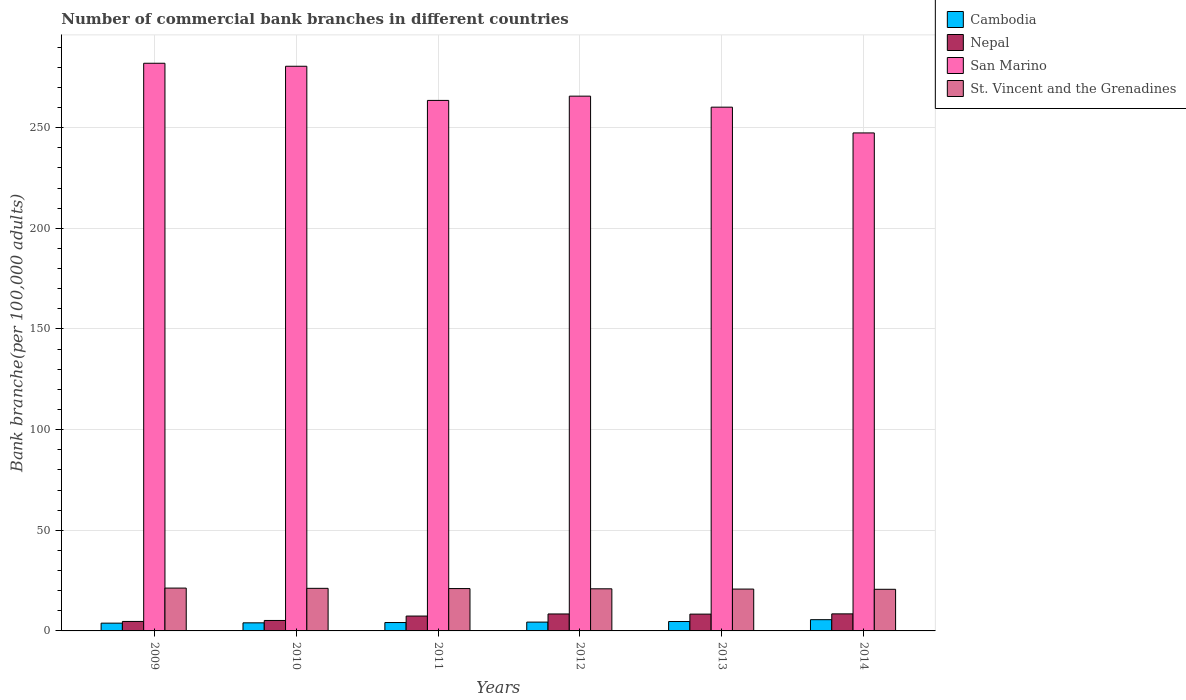How many groups of bars are there?
Offer a terse response. 6. Are the number of bars on each tick of the X-axis equal?
Offer a very short reply. Yes. What is the label of the 2nd group of bars from the left?
Offer a very short reply. 2010. In how many cases, is the number of bars for a given year not equal to the number of legend labels?
Make the answer very short. 0. What is the number of commercial bank branches in Cambodia in 2014?
Make the answer very short. 5.58. Across all years, what is the maximum number of commercial bank branches in Cambodia?
Your response must be concise. 5.58. Across all years, what is the minimum number of commercial bank branches in Nepal?
Keep it short and to the point. 4.71. What is the total number of commercial bank branches in St. Vincent and the Grenadines in the graph?
Ensure brevity in your answer.  125.89. What is the difference between the number of commercial bank branches in Cambodia in 2012 and that in 2014?
Keep it short and to the point. -1.2. What is the difference between the number of commercial bank branches in St. Vincent and the Grenadines in 2011 and the number of commercial bank branches in Nepal in 2013?
Your response must be concise. 12.69. What is the average number of commercial bank branches in St. Vincent and the Grenadines per year?
Provide a succinct answer. 20.98. In the year 2013, what is the difference between the number of commercial bank branches in San Marino and number of commercial bank branches in St. Vincent and the Grenadines?
Ensure brevity in your answer.  239.42. In how many years, is the number of commercial bank branches in Cambodia greater than 280?
Offer a very short reply. 0. What is the ratio of the number of commercial bank branches in Cambodia in 2009 to that in 2012?
Your answer should be very brief. 0.88. What is the difference between the highest and the second highest number of commercial bank branches in St. Vincent and the Grenadines?
Make the answer very short. 0.12. What is the difference between the highest and the lowest number of commercial bank branches in St. Vincent and the Grenadines?
Offer a very short reply. 0.6. In how many years, is the number of commercial bank branches in Cambodia greater than the average number of commercial bank branches in Cambodia taken over all years?
Ensure brevity in your answer.  2. Is it the case that in every year, the sum of the number of commercial bank branches in Nepal and number of commercial bank branches in St. Vincent and the Grenadines is greater than the sum of number of commercial bank branches in San Marino and number of commercial bank branches in Cambodia?
Your answer should be very brief. No. What does the 4th bar from the left in 2010 represents?
Make the answer very short. St. Vincent and the Grenadines. What does the 1st bar from the right in 2013 represents?
Offer a terse response. St. Vincent and the Grenadines. Is it the case that in every year, the sum of the number of commercial bank branches in Nepal and number of commercial bank branches in Cambodia is greater than the number of commercial bank branches in St. Vincent and the Grenadines?
Give a very brief answer. No. How many bars are there?
Offer a terse response. 24. Does the graph contain grids?
Offer a terse response. Yes. Where does the legend appear in the graph?
Provide a short and direct response. Top right. How are the legend labels stacked?
Offer a terse response. Vertical. What is the title of the graph?
Ensure brevity in your answer.  Number of commercial bank branches in different countries. Does "Korea (Republic)" appear as one of the legend labels in the graph?
Make the answer very short. No. What is the label or title of the Y-axis?
Give a very brief answer. Bank branche(per 100,0 adults). What is the Bank branche(per 100,000 adults) in Cambodia in 2009?
Provide a short and direct response. 3.86. What is the Bank branche(per 100,000 adults) of Nepal in 2009?
Offer a very short reply. 4.71. What is the Bank branche(per 100,000 adults) in San Marino in 2009?
Your answer should be very brief. 282.02. What is the Bank branche(per 100,000 adults) in St. Vincent and the Grenadines in 2009?
Your answer should be compact. 21.28. What is the Bank branche(per 100,000 adults) of Cambodia in 2010?
Offer a very short reply. 4.01. What is the Bank branche(per 100,000 adults) of Nepal in 2010?
Make the answer very short. 5.19. What is the Bank branche(per 100,000 adults) of San Marino in 2010?
Give a very brief answer. 280.53. What is the Bank branche(per 100,000 adults) in St. Vincent and the Grenadines in 2010?
Provide a short and direct response. 21.16. What is the Bank branche(per 100,000 adults) in Cambodia in 2011?
Give a very brief answer. 4.16. What is the Bank branche(per 100,000 adults) in Nepal in 2011?
Your answer should be very brief. 7.39. What is the Bank branche(per 100,000 adults) of San Marino in 2011?
Your answer should be very brief. 263.56. What is the Bank branche(per 100,000 adults) in St. Vincent and the Grenadines in 2011?
Give a very brief answer. 21.04. What is the Bank branche(per 100,000 adults) in Cambodia in 2012?
Provide a short and direct response. 4.38. What is the Bank branche(per 100,000 adults) of Nepal in 2012?
Your answer should be compact. 8.43. What is the Bank branche(per 100,000 adults) of San Marino in 2012?
Provide a succinct answer. 265.68. What is the Bank branche(per 100,000 adults) of St. Vincent and the Grenadines in 2012?
Give a very brief answer. 20.92. What is the Bank branche(per 100,000 adults) in Cambodia in 2013?
Ensure brevity in your answer.  4.67. What is the Bank branche(per 100,000 adults) of Nepal in 2013?
Offer a very short reply. 8.35. What is the Bank branche(per 100,000 adults) in San Marino in 2013?
Give a very brief answer. 260.21. What is the Bank branche(per 100,000 adults) of St. Vincent and the Grenadines in 2013?
Your answer should be compact. 20.8. What is the Bank branche(per 100,000 adults) in Cambodia in 2014?
Ensure brevity in your answer.  5.58. What is the Bank branche(per 100,000 adults) in Nepal in 2014?
Offer a very short reply. 8.47. What is the Bank branche(per 100,000 adults) of San Marino in 2014?
Give a very brief answer. 247.41. What is the Bank branche(per 100,000 adults) in St. Vincent and the Grenadines in 2014?
Ensure brevity in your answer.  20.69. Across all years, what is the maximum Bank branche(per 100,000 adults) in Cambodia?
Ensure brevity in your answer.  5.58. Across all years, what is the maximum Bank branche(per 100,000 adults) of Nepal?
Provide a short and direct response. 8.47. Across all years, what is the maximum Bank branche(per 100,000 adults) in San Marino?
Ensure brevity in your answer.  282.02. Across all years, what is the maximum Bank branche(per 100,000 adults) in St. Vincent and the Grenadines?
Ensure brevity in your answer.  21.28. Across all years, what is the minimum Bank branche(per 100,000 adults) in Cambodia?
Provide a short and direct response. 3.86. Across all years, what is the minimum Bank branche(per 100,000 adults) in Nepal?
Make the answer very short. 4.71. Across all years, what is the minimum Bank branche(per 100,000 adults) in San Marino?
Give a very brief answer. 247.41. Across all years, what is the minimum Bank branche(per 100,000 adults) in St. Vincent and the Grenadines?
Provide a succinct answer. 20.69. What is the total Bank branche(per 100,000 adults) of Cambodia in the graph?
Provide a short and direct response. 26.67. What is the total Bank branche(per 100,000 adults) of Nepal in the graph?
Your answer should be compact. 42.54. What is the total Bank branche(per 100,000 adults) of San Marino in the graph?
Provide a succinct answer. 1599.42. What is the total Bank branche(per 100,000 adults) of St. Vincent and the Grenadines in the graph?
Your answer should be compact. 125.89. What is the difference between the Bank branche(per 100,000 adults) in Cambodia in 2009 and that in 2010?
Your response must be concise. -0.15. What is the difference between the Bank branche(per 100,000 adults) of Nepal in 2009 and that in 2010?
Give a very brief answer. -0.49. What is the difference between the Bank branche(per 100,000 adults) in San Marino in 2009 and that in 2010?
Make the answer very short. 1.49. What is the difference between the Bank branche(per 100,000 adults) in St. Vincent and the Grenadines in 2009 and that in 2010?
Offer a very short reply. 0.12. What is the difference between the Bank branche(per 100,000 adults) in Cambodia in 2009 and that in 2011?
Your answer should be very brief. -0.3. What is the difference between the Bank branche(per 100,000 adults) in Nepal in 2009 and that in 2011?
Offer a very short reply. -2.68. What is the difference between the Bank branche(per 100,000 adults) in San Marino in 2009 and that in 2011?
Make the answer very short. 18.46. What is the difference between the Bank branche(per 100,000 adults) in St. Vincent and the Grenadines in 2009 and that in 2011?
Provide a short and direct response. 0.24. What is the difference between the Bank branche(per 100,000 adults) in Cambodia in 2009 and that in 2012?
Make the answer very short. -0.52. What is the difference between the Bank branche(per 100,000 adults) in Nepal in 2009 and that in 2012?
Provide a short and direct response. -3.72. What is the difference between the Bank branche(per 100,000 adults) of San Marino in 2009 and that in 2012?
Offer a terse response. 16.34. What is the difference between the Bank branche(per 100,000 adults) in St. Vincent and the Grenadines in 2009 and that in 2012?
Your answer should be compact. 0.36. What is the difference between the Bank branche(per 100,000 adults) in Cambodia in 2009 and that in 2013?
Your answer should be compact. -0.81. What is the difference between the Bank branche(per 100,000 adults) in Nepal in 2009 and that in 2013?
Your answer should be compact. -3.64. What is the difference between the Bank branche(per 100,000 adults) in San Marino in 2009 and that in 2013?
Offer a terse response. 21.81. What is the difference between the Bank branche(per 100,000 adults) of St. Vincent and the Grenadines in 2009 and that in 2013?
Keep it short and to the point. 0.49. What is the difference between the Bank branche(per 100,000 adults) in Cambodia in 2009 and that in 2014?
Offer a very short reply. -1.72. What is the difference between the Bank branche(per 100,000 adults) of Nepal in 2009 and that in 2014?
Keep it short and to the point. -3.76. What is the difference between the Bank branche(per 100,000 adults) in San Marino in 2009 and that in 2014?
Provide a succinct answer. 34.61. What is the difference between the Bank branche(per 100,000 adults) of St. Vincent and the Grenadines in 2009 and that in 2014?
Give a very brief answer. 0.6. What is the difference between the Bank branche(per 100,000 adults) in Cambodia in 2010 and that in 2011?
Provide a succinct answer. -0.15. What is the difference between the Bank branche(per 100,000 adults) of Nepal in 2010 and that in 2011?
Your answer should be very brief. -2.19. What is the difference between the Bank branche(per 100,000 adults) in San Marino in 2010 and that in 2011?
Give a very brief answer. 16.97. What is the difference between the Bank branche(per 100,000 adults) of St. Vincent and the Grenadines in 2010 and that in 2011?
Give a very brief answer. 0.12. What is the difference between the Bank branche(per 100,000 adults) in Cambodia in 2010 and that in 2012?
Make the answer very short. -0.37. What is the difference between the Bank branche(per 100,000 adults) in Nepal in 2010 and that in 2012?
Your response must be concise. -3.23. What is the difference between the Bank branche(per 100,000 adults) of San Marino in 2010 and that in 2012?
Make the answer very short. 14.85. What is the difference between the Bank branche(per 100,000 adults) of St. Vincent and the Grenadines in 2010 and that in 2012?
Your answer should be very brief. 0.24. What is the difference between the Bank branche(per 100,000 adults) in Cambodia in 2010 and that in 2013?
Make the answer very short. -0.66. What is the difference between the Bank branche(per 100,000 adults) of Nepal in 2010 and that in 2013?
Your answer should be compact. -3.16. What is the difference between the Bank branche(per 100,000 adults) of San Marino in 2010 and that in 2013?
Provide a short and direct response. 20.32. What is the difference between the Bank branche(per 100,000 adults) in St. Vincent and the Grenadines in 2010 and that in 2013?
Provide a succinct answer. 0.36. What is the difference between the Bank branche(per 100,000 adults) in Cambodia in 2010 and that in 2014?
Ensure brevity in your answer.  -1.57. What is the difference between the Bank branche(per 100,000 adults) in Nepal in 2010 and that in 2014?
Your response must be concise. -3.28. What is the difference between the Bank branche(per 100,000 adults) of San Marino in 2010 and that in 2014?
Offer a terse response. 33.12. What is the difference between the Bank branche(per 100,000 adults) of St. Vincent and the Grenadines in 2010 and that in 2014?
Your response must be concise. 0.47. What is the difference between the Bank branche(per 100,000 adults) in Cambodia in 2011 and that in 2012?
Your answer should be compact. -0.22. What is the difference between the Bank branche(per 100,000 adults) of Nepal in 2011 and that in 2012?
Your answer should be compact. -1.04. What is the difference between the Bank branche(per 100,000 adults) in San Marino in 2011 and that in 2012?
Your response must be concise. -2.12. What is the difference between the Bank branche(per 100,000 adults) in St. Vincent and the Grenadines in 2011 and that in 2012?
Ensure brevity in your answer.  0.12. What is the difference between the Bank branche(per 100,000 adults) in Cambodia in 2011 and that in 2013?
Your answer should be compact. -0.5. What is the difference between the Bank branche(per 100,000 adults) of Nepal in 2011 and that in 2013?
Provide a succinct answer. -0.97. What is the difference between the Bank branche(per 100,000 adults) in San Marino in 2011 and that in 2013?
Keep it short and to the point. 3.35. What is the difference between the Bank branche(per 100,000 adults) in St. Vincent and the Grenadines in 2011 and that in 2013?
Provide a short and direct response. 0.24. What is the difference between the Bank branche(per 100,000 adults) of Cambodia in 2011 and that in 2014?
Offer a terse response. -1.42. What is the difference between the Bank branche(per 100,000 adults) in Nepal in 2011 and that in 2014?
Ensure brevity in your answer.  -1.09. What is the difference between the Bank branche(per 100,000 adults) in San Marino in 2011 and that in 2014?
Offer a terse response. 16.15. What is the difference between the Bank branche(per 100,000 adults) of St. Vincent and the Grenadines in 2011 and that in 2014?
Give a very brief answer. 0.35. What is the difference between the Bank branche(per 100,000 adults) of Cambodia in 2012 and that in 2013?
Offer a terse response. -0.29. What is the difference between the Bank branche(per 100,000 adults) in Nepal in 2012 and that in 2013?
Give a very brief answer. 0.08. What is the difference between the Bank branche(per 100,000 adults) in San Marino in 2012 and that in 2013?
Offer a terse response. 5.47. What is the difference between the Bank branche(per 100,000 adults) in St. Vincent and the Grenadines in 2012 and that in 2013?
Provide a short and direct response. 0.12. What is the difference between the Bank branche(per 100,000 adults) of Cambodia in 2012 and that in 2014?
Keep it short and to the point. -1.2. What is the difference between the Bank branche(per 100,000 adults) of Nepal in 2012 and that in 2014?
Your answer should be very brief. -0.04. What is the difference between the Bank branche(per 100,000 adults) in San Marino in 2012 and that in 2014?
Ensure brevity in your answer.  18.27. What is the difference between the Bank branche(per 100,000 adults) of St. Vincent and the Grenadines in 2012 and that in 2014?
Your answer should be compact. 0.23. What is the difference between the Bank branche(per 100,000 adults) of Cambodia in 2013 and that in 2014?
Provide a succinct answer. -0.92. What is the difference between the Bank branche(per 100,000 adults) in Nepal in 2013 and that in 2014?
Your response must be concise. -0.12. What is the difference between the Bank branche(per 100,000 adults) in San Marino in 2013 and that in 2014?
Keep it short and to the point. 12.8. What is the difference between the Bank branche(per 100,000 adults) of St. Vincent and the Grenadines in 2013 and that in 2014?
Ensure brevity in your answer.  0.11. What is the difference between the Bank branche(per 100,000 adults) of Cambodia in 2009 and the Bank branche(per 100,000 adults) of Nepal in 2010?
Make the answer very short. -1.33. What is the difference between the Bank branche(per 100,000 adults) of Cambodia in 2009 and the Bank branche(per 100,000 adults) of San Marino in 2010?
Keep it short and to the point. -276.67. What is the difference between the Bank branche(per 100,000 adults) of Cambodia in 2009 and the Bank branche(per 100,000 adults) of St. Vincent and the Grenadines in 2010?
Your answer should be very brief. -17.3. What is the difference between the Bank branche(per 100,000 adults) in Nepal in 2009 and the Bank branche(per 100,000 adults) in San Marino in 2010?
Provide a short and direct response. -275.82. What is the difference between the Bank branche(per 100,000 adults) in Nepal in 2009 and the Bank branche(per 100,000 adults) in St. Vincent and the Grenadines in 2010?
Offer a very short reply. -16.45. What is the difference between the Bank branche(per 100,000 adults) in San Marino in 2009 and the Bank branche(per 100,000 adults) in St. Vincent and the Grenadines in 2010?
Provide a succinct answer. 260.86. What is the difference between the Bank branche(per 100,000 adults) in Cambodia in 2009 and the Bank branche(per 100,000 adults) in Nepal in 2011?
Your answer should be very brief. -3.52. What is the difference between the Bank branche(per 100,000 adults) in Cambodia in 2009 and the Bank branche(per 100,000 adults) in San Marino in 2011?
Ensure brevity in your answer.  -259.7. What is the difference between the Bank branche(per 100,000 adults) in Cambodia in 2009 and the Bank branche(per 100,000 adults) in St. Vincent and the Grenadines in 2011?
Offer a very short reply. -17.18. What is the difference between the Bank branche(per 100,000 adults) in Nepal in 2009 and the Bank branche(per 100,000 adults) in San Marino in 2011?
Ensure brevity in your answer.  -258.86. What is the difference between the Bank branche(per 100,000 adults) of Nepal in 2009 and the Bank branche(per 100,000 adults) of St. Vincent and the Grenadines in 2011?
Ensure brevity in your answer.  -16.33. What is the difference between the Bank branche(per 100,000 adults) in San Marino in 2009 and the Bank branche(per 100,000 adults) in St. Vincent and the Grenadines in 2011?
Offer a terse response. 260.98. What is the difference between the Bank branche(per 100,000 adults) of Cambodia in 2009 and the Bank branche(per 100,000 adults) of Nepal in 2012?
Your response must be concise. -4.57. What is the difference between the Bank branche(per 100,000 adults) of Cambodia in 2009 and the Bank branche(per 100,000 adults) of San Marino in 2012?
Keep it short and to the point. -261.82. What is the difference between the Bank branche(per 100,000 adults) in Cambodia in 2009 and the Bank branche(per 100,000 adults) in St. Vincent and the Grenadines in 2012?
Your answer should be compact. -17.06. What is the difference between the Bank branche(per 100,000 adults) of Nepal in 2009 and the Bank branche(per 100,000 adults) of San Marino in 2012?
Your answer should be very brief. -260.97. What is the difference between the Bank branche(per 100,000 adults) of Nepal in 2009 and the Bank branche(per 100,000 adults) of St. Vincent and the Grenadines in 2012?
Make the answer very short. -16.21. What is the difference between the Bank branche(per 100,000 adults) in San Marino in 2009 and the Bank branche(per 100,000 adults) in St. Vincent and the Grenadines in 2012?
Offer a terse response. 261.1. What is the difference between the Bank branche(per 100,000 adults) of Cambodia in 2009 and the Bank branche(per 100,000 adults) of Nepal in 2013?
Ensure brevity in your answer.  -4.49. What is the difference between the Bank branche(per 100,000 adults) in Cambodia in 2009 and the Bank branche(per 100,000 adults) in San Marino in 2013?
Provide a succinct answer. -256.35. What is the difference between the Bank branche(per 100,000 adults) in Cambodia in 2009 and the Bank branche(per 100,000 adults) in St. Vincent and the Grenadines in 2013?
Your answer should be compact. -16.93. What is the difference between the Bank branche(per 100,000 adults) in Nepal in 2009 and the Bank branche(per 100,000 adults) in San Marino in 2013?
Your answer should be very brief. -255.5. What is the difference between the Bank branche(per 100,000 adults) of Nepal in 2009 and the Bank branche(per 100,000 adults) of St. Vincent and the Grenadines in 2013?
Give a very brief answer. -16.09. What is the difference between the Bank branche(per 100,000 adults) in San Marino in 2009 and the Bank branche(per 100,000 adults) in St. Vincent and the Grenadines in 2013?
Offer a terse response. 261.23. What is the difference between the Bank branche(per 100,000 adults) in Cambodia in 2009 and the Bank branche(per 100,000 adults) in Nepal in 2014?
Keep it short and to the point. -4.61. What is the difference between the Bank branche(per 100,000 adults) of Cambodia in 2009 and the Bank branche(per 100,000 adults) of San Marino in 2014?
Your response must be concise. -243.55. What is the difference between the Bank branche(per 100,000 adults) in Cambodia in 2009 and the Bank branche(per 100,000 adults) in St. Vincent and the Grenadines in 2014?
Your response must be concise. -16.83. What is the difference between the Bank branche(per 100,000 adults) in Nepal in 2009 and the Bank branche(per 100,000 adults) in San Marino in 2014?
Keep it short and to the point. -242.7. What is the difference between the Bank branche(per 100,000 adults) in Nepal in 2009 and the Bank branche(per 100,000 adults) in St. Vincent and the Grenadines in 2014?
Keep it short and to the point. -15.98. What is the difference between the Bank branche(per 100,000 adults) of San Marino in 2009 and the Bank branche(per 100,000 adults) of St. Vincent and the Grenadines in 2014?
Provide a short and direct response. 261.33. What is the difference between the Bank branche(per 100,000 adults) of Cambodia in 2010 and the Bank branche(per 100,000 adults) of Nepal in 2011?
Give a very brief answer. -3.37. What is the difference between the Bank branche(per 100,000 adults) in Cambodia in 2010 and the Bank branche(per 100,000 adults) in San Marino in 2011?
Give a very brief answer. -259.55. What is the difference between the Bank branche(per 100,000 adults) of Cambodia in 2010 and the Bank branche(per 100,000 adults) of St. Vincent and the Grenadines in 2011?
Ensure brevity in your answer.  -17.02. What is the difference between the Bank branche(per 100,000 adults) of Nepal in 2010 and the Bank branche(per 100,000 adults) of San Marino in 2011?
Provide a succinct answer. -258.37. What is the difference between the Bank branche(per 100,000 adults) of Nepal in 2010 and the Bank branche(per 100,000 adults) of St. Vincent and the Grenadines in 2011?
Make the answer very short. -15.84. What is the difference between the Bank branche(per 100,000 adults) in San Marino in 2010 and the Bank branche(per 100,000 adults) in St. Vincent and the Grenadines in 2011?
Your answer should be very brief. 259.49. What is the difference between the Bank branche(per 100,000 adults) in Cambodia in 2010 and the Bank branche(per 100,000 adults) in Nepal in 2012?
Provide a succinct answer. -4.42. What is the difference between the Bank branche(per 100,000 adults) in Cambodia in 2010 and the Bank branche(per 100,000 adults) in San Marino in 2012?
Your answer should be very brief. -261.67. What is the difference between the Bank branche(per 100,000 adults) in Cambodia in 2010 and the Bank branche(per 100,000 adults) in St. Vincent and the Grenadines in 2012?
Offer a very short reply. -16.91. What is the difference between the Bank branche(per 100,000 adults) of Nepal in 2010 and the Bank branche(per 100,000 adults) of San Marino in 2012?
Offer a very short reply. -260.49. What is the difference between the Bank branche(per 100,000 adults) of Nepal in 2010 and the Bank branche(per 100,000 adults) of St. Vincent and the Grenadines in 2012?
Give a very brief answer. -15.73. What is the difference between the Bank branche(per 100,000 adults) in San Marino in 2010 and the Bank branche(per 100,000 adults) in St. Vincent and the Grenadines in 2012?
Ensure brevity in your answer.  259.61. What is the difference between the Bank branche(per 100,000 adults) in Cambodia in 2010 and the Bank branche(per 100,000 adults) in Nepal in 2013?
Provide a short and direct response. -4.34. What is the difference between the Bank branche(per 100,000 adults) in Cambodia in 2010 and the Bank branche(per 100,000 adults) in San Marino in 2013?
Offer a terse response. -256.2. What is the difference between the Bank branche(per 100,000 adults) of Cambodia in 2010 and the Bank branche(per 100,000 adults) of St. Vincent and the Grenadines in 2013?
Offer a very short reply. -16.78. What is the difference between the Bank branche(per 100,000 adults) in Nepal in 2010 and the Bank branche(per 100,000 adults) in San Marino in 2013?
Ensure brevity in your answer.  -255.02. What is the difference between the Bank branche(per 100,000 adults) of Nepal in 2010 and the Bank branche(per 100,000 adults) of St. Vincent and the Grenadines in 2013?
Provide a succinct answer. -15.6. What is the difference between the Bank branche(per 100,000 adults) of San Marino in 2010 and the Bank branche(per 100,000 adults) of St. Vincent and the Grenadines in 2013?
Offer a very short reply. 259.74. What is the difference between the Bank branche(per 100,000 adults) in Cambodia in 2010 and the Bank branche(per 100,000 adults) in Nepal in 2014?
Your response must be concise. -4.46. What is the difference between the Bank branche(per 100,000 adults) of Cambodia in 2010 and the Bank branche(per 100,000 adults) of San Marino in 2014?
Give a very brief answer. -243.4. What is the difference between the Bank branche(per 100,000 adults) in Cambodia in 2010 and the Bank branche(per 100,000 adults) in St. Vincent and the Grenadines in 2014?
Your answer should be very brief. -16.67. What is the difference between the Bank branche(per 100,000 adults) of Nepal in 2010 and the Bank branche(per 100,000 adults) of San Marino in 2014?
Make the answer very short. -242.22. What is the difference between the Bank branche(per 100,000 adults) of Nepal in 2010 and the Bank branche(per 100,000 adults) of St. Vincent and the Grenadines in 2014?
Your response must be concise. -15.49. What is the difference between the Bank branche(per 100,000 adults) in San Marino in 2010 and the Bank branche(per 100,000 adults) in St. Vincent and the Grenadines in 2014?
Your answer should be very brief. 259.84. What is the difference between the Bank branche(per 100,000 adults) in Cambodia in 2011 and the Bank branche(per 100,000 adults) in Nepal in 2012?
Provide a succinct answer. -4.26. What is the difference between the Bank branche(per 100,000 adults) of Cambodia in 2011 and the Bank branche(per 100,000 adults) of San Marino in 2012?
Provide a succinct answer. -261.52. What is the difference between the Bank branche(per 100,000 adults) in Cambodia in 2011 and the Bank branche(per 100,000 adults) in St. Vincent and the Grenadines in 2012?
Provide a short and direct response. -16.76. What is the difference between the Bank branche(per 100,000 adults) in Nepal in 2011 and the Bank branche(per 100,000 adults) in San Marino in 2012?
Your answer should be compact. -258.29. What is the difference between the Bank branche(per 100,000 adults) in Nepal in 2011 and the Bank branche(per 100,000 adults) in St. Vincent and the Grenadines in 2012?
Offer a terse response. -13.53. What is the difference between the Bank branche(per 100,000 adults) of San Marino in 2011 and the Bank branche(per 100,000 adults) of St. Vincent and the Grenadines in 2012?
Keep it short and to the point. 242.64. What is the difference between the Bank branche(per 100,000 adults) of Cambodia in 2011 and the Bank branche(per 100,000 adults) of Nepal in 2013?
Your answer should be compact. -4.19. What is the difference between the Bank branche(per 100,000 adults) in Cambodia in 2011 and the Bank branche(per 100,000 adults) in San Marino in 2013?
Offer a terse response. -256.05. What is the difference between the Bank branche(per 100,000 adults) in Cambodia in 2011 and the Bank branche(per 100,000 adults) in St. Vincent and the Grenadines in 2013?
Offer a terse response. -16.63. What is the difference between the Bank branche(per 100,000 adults) of Nepal in 2011 and the Bank branche(per 100,000 adults) of San Marino in 2013?
Your response must be concise. -252.83. What is the difference between the Bank branche(per 100,000 adults) in Nepal in 2011 and the Bank branche(per 100,000 adults) in St. Vincent and the Grenadines in 2013?
Keep it short and to the point. -13.41. What is the difference between the Bank branche(per 100,000 adults) of San Marino in 2011 and the Bank branche(per 100,000 adults) of St. Vincent and the Grenadines in 2013?
Your answer should be very brief. 242.77. What is the difference between the Bank branche(per 100,000 adults) of Cambodia in 2011 and the Bank branche(per 100,000 adults) of Nepal in 2014?
Provide a succinct answer. -4.31. What is the difference between the Bank branche(per 100,000 adults) in Cambodia in 2011 and the Bank branche(per 100,000 adults) in San Marino in 2014?
Give a very brief answer. -243.25. What is the difference between the Bank branche(per 100,000 adults) in Cambodia in 2011 and the Bank branche(per 100,000 adults) in St. Vincent and the Grenadines in 2014?
Make the answer very short. -16.52. What is the difference between the Bank branche(per 100,000 adults) in Nepal in 2011 and the Bank branche(per 100,000 adults) in San Marino in 2014?
Ensure brevity in your answer.  -240.02. What is the difference between the Bank branche(per 100,000 adults) of Nepal in 2011 and the Bank branche(per 100,000 adults) of St. Vincent and the Grenadines in 2014?
Ensure brevity in your answer.  -13.3. What is the difference between the Bank branche(per 100,000 adults) of San Marino in 2011 and the Bank branche(per 100,000 adults) of St. Vincent and the Grenadines in 2014?
Keep it short and to the point. 242.88. What is the difference between the Bank branche(per 100,000 adults) of Cambodia in 2012 and the Bank branche(per 100,000 adults) of Nepal in 2013?
Your answer should be compact. -3.97. What is the difference between the Bank branche(per 100,000 adults) of Cambodia in 2012 and the Bank branche(per 100,000 adults) of San Marino in 2013?
Give a very brief answer. -255.83. What is the difference between the Bank branche(per 100,000 adults) in Cambodia in 2012 and the Bank branche(per 100,000 adults) in St. Vincent and the Grenadines in 2013?
Your response must be concise. -16.41. What is the difference between the Bank branche(per 100,000 adults) in Nepal in 2012 and the Bank branche(per 100,000 adults) in San Marino in 2013?
Your answer should be very brief. -251.78. What is the difference between the Bank branche(per 100,000 adults) of Nepal in 2012 and the Bank branche(per 100,000 adults) of St. Vincent and the Grenadines in 2013?
Keep it short and to the point. -12.37. What is the difference between the Bank branche(per 100,000 adults) in San Marino in 2012 and the Bank branche(per 100,000 adults) in St. Vincent and the Grenadines in 2013?
Give a very brief answer. 244.88. What is the difference between the Bank branche(per 100,000 adults) of Cambodia in 2012 and the Bank branche(per 100,000 adults) of Nepal in 2014?
Ensure brevity in your answer.  -4.09. What is the difference between the Bank branche(per 100,000 adults) in Cambodia in 2012 and the Bank branche(per 100,000 adults) in San Marino in 2014?
Your answer should be very brief. -243.03. What is the difference between the Bank branche(per 100,000 adults) of Cambodia in 2012 and the Bank branche(per 100,000 adults) of St. Vincent and the Grenadines in 2014?
Make the answer very short. -16.3. What is the difference between the Bank branche(per 100,000 adults) in Nepal in 2012 and the Bank branche(per 100,000 adults) in San Marino in 2014?
Provide a succinct answer. -238.98. What is the difference between the Bank branche(per 100,000 adults) of Nepal in 2012 and the Bank branche(per 100,000 adults) of St. Vincent and the Grenadines in 2014?
Provide a succinct answer. -12.26. What is the difference between the Bank branche(per 100,000 adults) in San Marino in 2012 and the Bank branche(per 100,000 adults) in St. Vincent and the Grenadines in 2014?
Your response must be concise. 244.99. What is the difference between the Bank branche(per 100,000 adults) of Cambodia in 2013 and the Bank branche(per 100,000 adults) of Nepal in 2014?
Offer a very short reply. -3.8. What is the difference between the Bank branche(per 100,000 adults) of Cambodia in 2013 and the Bank branche(per 100,000 adults) of San Marino in 2014?
Make the answer very short. -242.74. What is the difference between the Bank branche(per 100,000 adults) in Cambodia in 2013 and the Bank branche(per 100,000 adults) in St. Vincent and the Grenadines in 2014?
Give a very brief answer. -16.02. What is the difference between the Bank branche(per 100,000 adults) in Nepal in 2013 and the Bank branche(per 100,000 adults) in San Marino in 2014?
Keep it short and to the point. -239.06. What is the difference between the Bank branche(per 100,000 adults) of Nepal in 2013 and the Bank branche(per 100,000 adults) of St. Vincent and the Grenadines in 2014?
Ensure brevity in your answer.  -12.34. What is the difference between the Bank branche(per 100,000 adults) of San Marino in 2013 and the Bank branche(per 100,000 adults) of St. Vincent and the Grenadines in 2014?
Offer a very short reply. 239.52. What is the average Bank branche(per 100,000 adults) of Cambodia per year?
Offer a very short reply. 4.45. What is the average Bank branche(per 100,000 adults) of Nepal per year?
Give a very brief answer. 7.09. What is the average Bank branche(per 100,000 adults) of San Marino per year?
Offer a very short reply. 266.57. What is the average Bank branche(per 100,000 adults) of St. Vincent and the Grenadines per year?
Make the answer very short. 20.98. In the year 2009, what is the difference between the Bank branche(per 100,000 adults) in Cambodia and Bank branche(per 100,000 adults) in Nepal?
Your answer should be very brief. -0.85. In the year 2009, what is the difference between the Bank branche(per 100,000 adults) in Cambodia and Bank branche(per 100,000 adults) in San Marino?
Give a very brief answer. -278.16. In the year 2009, what is the difference between the Bank branche(per 100,000 adults) in Cambodia and Bank branche(per 100,000 adults) in St. Vincent and the Grenadines?
Your answer should be compact. -17.42. In the year 2009, what is the difference between the Bank branche(per 100,000 adults) in Nepal and Bank branche(per 100,000 adults) in San Marino?
Your answer should be compact. -277.31. In the year 2009, what is the difference between the Bank branche(per 100,000 adults) in Nepal and Bank branche(per 100,000 adults) in St. Vincent and the Grenadines?
Provide a short and direct response. -16.58. In the year 2009, what is the difference between the Bank branche(per 100,000 adults) in San Marino and Bank branche(per 100,000 adults) in St. Vincent and the Grenadines?
Give a very brief answer. 260.74. In the year 2010, what is the difference between the Bank branche(per 100,000 adults) in Cambodia and Bank branche(per 100,000 adults) in Nepal?
Keep it short and to the point. -1.18. In the year 2010, what is the difference between the Bank branche(per 100,000 adults) in Cambodia and Bank branche(per 100,000 adults) in San Marino?
Make the answer very short. -276.52. In the year 2010, what is the difference between the Bank branche(per 100,000 adults) in Cambodia and Bank branche(per 100,000 adults) in St. Vincent and the Grenadines?
Your response must be concise. -17.15. In the year 2010, what is the difference between the Bank branche(per 100,000 adults) in Nepal and Bank branche(per 100,000 adults) in San Marino?
Your answer should be compact. -275.34. In the year 2010, what is the difference between the Bank branche(per 100,000 adults) of Nepal and Bank branche(per 100,000 adults) of St. Vincent and the Grenadines?
Your answer should be compact. -15.97. In the year 2010, what is the difference between the Bank branche(per 100,000 adults) in San Marino and Bank branche(per 100,000 adults) in St. Vincent and the Grenadines?
Your answer should be compact. 259.37. In the year 2011, what is the difference between the Bank branche(per 100,000 adults) in Cambodia and Bank branche(per 100,000 adults) in Nepal?
Make the answer very short. -3.22. In the year 2011, what is the difference between the Bank branche(per 100,000 adults) of Cambodia and Bank branche(per 100,000 adults) of San Marino?
Your response must be concise. -259.4. In the year 2011, what is the difference between the Bank branche(per 100,000 adults) of Cambodia and Bank branche(per 100,000 adults) of St. Vincent and the Grenadines?
Ensure brevity in your answer.  -16.87. In the year 2011, what is the difference between the Bank branche(per 100,000 adults) in Nepal and Bank branche(per 100,000 adults) in San Marino?
Your answer should be very brief. -256.18. In the year 2011, what is the difference between the Bank branche(per 100,000 adults) in Nepal and Bank branche(per 100,000 adults) in St. Vincent and the Grenadines?
Your response must be concise. -13.65. In the year 2011, what is the difference between the Bank branche(per 100,000 adults) of San Marino and Bank branche(per 100,000 adults) of St. Vincent and the Grenadines?
Provide a succinct answer. 242.52. In the year 2012, what is the difference between the Bank branche(per 100,000 adults) of Cambodia and Bank branche(per 100,000 adults) of Nepal?
Your response must be concise. -4.05. In the year 2012, what is the difference between the Bank branche(per 100,000 adults) in Cambodia and Bank branche(per 100,000 adults) in San Marino?
Make the answer very short. -261.3. In the year 2012, what is the difference between the Bank branche(per 100,000 adults) of Cambodia and Bank branche(per 100,000 adults) of St. Vincent and the Grenadines?
Your answer should be compact. -16.54. In the year 2012, what is the difference between the Bank branche(per 100,000 adults) of Nepal and Bank branche(per 100,000 adults) of San Marino?
Offer a terse response. -257.25. In the year 2012, what is the difference between the Bank branche(per 100,000 adults) of Nepal and Bank branche(per 100,000 adults) of St. Vincent and the Grenadines?
Give a very brief answer. -12.49. In the year 2012, what is the difference between the Bank branche(per 100,000 adults) of San Marino and Bank branche(per 100,000 adults) of St. Vincent and the Grenadines?
Provide a short and direct response. 244.76. In the year 2013, what is the difference between the Bank branche(per 100,000 adults) in Cambodia and Bank branche(per 100,000 adults) in Nepal?
Provide a short and direct response. -3.68. In the year 2013, what is the difference between the Bank branche(per 100,000 adults) of Cambodia and Bank branche(per 100,000 adults) of San Marino?
Ensure brevity in your answer.  -255.54. In the year 2013, what is the difference between the Bank branche(per 100,000 adults) in Cambodia and Bank branche(per 100,000 adults) in St. Vincent and the Grenadines?
Provide a short and direct response. -16.13. In the year 2013, what is the difference between the Bank branche(per 100,000 adults) in Nepal and Bank branche(per 100,000 adults) in San Marino?
Give a very brief answer. -251.86. In the year 2013, what is the difference between the Bank branche(per 100,000 adults) in Nepal and Bank branche(per 100,000 adults) in St. Vincent and the Grenadines?
Make the answer very short. -12.44. In the year 2013, what is the difference between the Bank branche(per 100,000 adults) in San Marino and Bank branche(per 100,000 adults) in St. Vincent and the Grenadines?
Give a very brief answer. 239.41. In the year 2014, what is the difference between the Bank branche(per 100,000 adults) of Cambodia and Bank branche(per 100,000 adults) of Nepal?
Offer a very short reply. -2.89. In the year 2014, what is the difference between the Bank branche(per 100,000 adults) of Cambodia and Bank branche(per 100,000 adults) of San Marino?
Keep it short and to the point. -241.83. In the year 2014, what is the difference between the Bank branche(per 100,000 adults) in Cambodia and Bank branche(per 100,000 adults) in St. Vincent and the Grenadines?
Give a very brief answer. -15.1. In the year 2014, what is the difference between the Bank branche(per 100,000 adults) in Nepal and Bank branche(per 100,000 adults) in San Marino?
Your answer should be very brief. -238.94. In the year 2014, what is the difference between the Bank branche(per 100,000 adults) of Nepal and Bank branche(per 100,000 adults) of St. Vincent and the Grenadines?
Make the answer very short. -12.21. In the year 2014, what is the difference between the Bank branche(per 100,000 adults) of San Marino and Bank branche(per 100,000 adults) of St. Vincent and the Grenadines?
Keep it short and to the point. 226.72. What is the ratio of the Bank branche(per 100,000 adults) in Cambodia in 2009 to that in 2010?
Offer a very short reply. 0.96. What is the ratio of the Bank branche(per 100,000 adults) of Nepal in 2009 to that in 2010?
Offer a very short reply. 0.91. What is the ratio of the Bank branche(per 100,000 adults) of San Marino in 2009 to that in 2010?
Keep it short and to the point. 1.01. What is the ratio of the Bank branche(per 100,000 adults) in Cambodia in 2009 to that in 2011?
Provide a short and direct response. 0.93. What is the ratio of the Bank branche(per 100,000 adults) in Nepal in 2009 to that in 2011?
Give a very brief answer. 0.64. What is the ratio of the Bank branche(per 100,000 adults) in San Marino in 2009 to that in 2011?
Provide a short and direct response. 1.07. What is the ratio of the Bank branche(per 100,000 adults) in St. Vincent and the Grenadines in 2009 to that in 2011?
Your response must be concise. 1.01. What is the ratio of the Bank branche(per 100,000 adults) of Cambodia in 2009 to that in 2012?
Your answer should be compact. 0.88. What is the ratio of the Bank branche(per 100,000 adults) in Nepal in 2009 to that in 2012?
Keep it short and to the point. 0.56. What is the ratio of the Bank branche(per 100,000 adults) of San Marino in 2009 to that in 2012?
Offer a very short reply. 1.06. What is the ratio of the Bank branche(per 100,000 adults) of St. Vincent and the Grenadines in 2009 to that in 2012?
Your response must be concise. 1.02. What is the ratio of the Bank branche(per 100,000 adults) of Cambodia in 2009 to that in 2013?
Offer a very short reply. 0.83. What is the ratio of the Bank branche(per 100,000 adults) in Nepal in 2009 to that in 2013?
Offer a very short reply. 0.56. What is the ratio of the Bank branche(per 100,000 adults) of San Marino in 2009 to that in 2013?
Keep it short and to the point. 1.08. What is the ratio of the Bank branche(per 100,000 adults) in St. Vincent and the Grenadines in 2009 to that in 2013?
Offer a terse response. 1.02. What is the ratio of the Bank branche(per 100,000 adults) in Cambodia in 2009 to that in 2014?
Make the answer very short. 0.69. What is the ratio of the Bank branche(per 100,000 adults) of Nepal in 2009 to that in 2014?
Make the answer very short. 0.56. What is the ratio of the Bank branche(per 100,000 adults) in San Marino in 2009 to that in 2014?
Provide a succinct answer. 1.14. What is the ratio of the Bank branche(per 100,000 adults) of St. Vincent and the Grenadines in 2009 to that in 2014?
Give a very brief answer. 1.03. What is the ratio of the Bank branche(per 100,000 adults) in Cambodia in 2010 to that in 2011?
Ensure brevity in your answer.  0.96. What is the ratio of the Bank branche(per 100,000 adults) of Nepal in 2010 to that in 2011?
Offer a very short reply. 0.7. What is the ratio of the Bank branche(per 100,000 adults) of San Marino in 2010 to that in 2011?
Your answer should be very brief. 1.06. What is the ratio of the Bank branche(per 100,000 adults) of Cambodia in 2010 to that in 2012?
Your answer should be compact. 0.92. What is the ratio of the Bank branche(per 100,000 adults) in Nepal in 2010 to that in 2012?
Offer a very short reply. 0.62. What is the ratio of the Bank branche(per 100,000 adults) of San Marino in 2010 to that in 2012?
Offer a very short reply. 1.06. What is the ratio of the Bank branche(per 100,000 adults) of St. Vincent and the Grenadines in 2010 to that in 2012?
Keep it short and to the point. 1.01. What is the ratio of the Bank branche(per 100,000 adults) in Cambodia in 2010 to that in 2013?
Offer a terse response. 0.86. What is the ratio of the Bank branche(per 100,000 adults) in Nepal in 2010 to that in 2013?
Your answer should be compact. 0.62. What is the ratio of the Bank branche(per 100,000 adults) in San Marino in 2010 to that in 2013?
Keep it short and to the point. 1.08. What is the ratio of the Bank branche(per 100,000 adults) in St. Vincent and the Grenadines in 2010 to that in 2013?
Keep it short and to the point. 1.02. What is the ratio of the Bank branche(per 100,000 adults) in Cambodia in 2010 to that in 2014?
Give a very brief answer. 0.72. What is the ratio of the Bank branche(per 100,000 adults) of Nepal in 2010 to that in 2014?
Give a very brief answer. 0.61. What is the ratio of the Bank branche(per 100,000 adults) in San Marino in 2010 to that in 2014?
Make the answer very short. 1.13. What is the ratio of the Bank branche(per 100,000 adults) in St. Vincent and the Grenadines in 2010 to that in 2014?
Give a very brief answer. 1.02. What is the ratio of the Bank branche(per 100,000 adults) of Cambodia in 2011 to that in 2012?
Your response must be concise. 0.95. What is the ratio of the Bank branche(per 100,000 adults) in Nepal in 2011 to that in 2012?
Your response must be concise. 0.88. What is the ratio of the Bank branche(per 100,000 adults) in St. Vincent and the Grenadines in 2011 to that in 2012?
Your response must be concise. 1.01. What is the ratio of the Bank branche(per 100,000 adults) in Cambodia in 2011 to that in 2013?
Make the answer very short. 0.89. What is the ratio of the Bank branche(per 100,000 adults) in Nepal in 2011 to that in 2013?
Make the answer very short. 0.88. What is the ratio of the Bank branche(per 100,000 adults) in San Marino in 2011 to that in 2013?
Offer a terse response. 1.01. What is the ratio of the Bank branche(per 100,000 adults) in St. Vincent and the Grenadines in 2011 to that in 2013?
Keep it short and to the point. 1.01. What is the ratio of the Bank branche(per 100,000 adults) of Cambodia in 2011 to that in 2014?
Your answer should be compact. 0.75. What is the ratio of the Bank branche(per 100,000 adults) in Nepal in 2011 to that in 2014?
Give a very brief answer. 0.87. What is the ratio of the Bank branche(per 100,000 adults) in San Marino in 2011 to that in 2014?
Keep it short and to the point. 1.07. What is the ratio of the Bank branche(per 100,000 adults) in Cambodia in 2012 to that in 2013?
Give a very brief answer. 0.94. What is the ratio of the Bank branche(per 100,000 adults) in Nepal in 2012 to that in 2013?
Ensure brevity in your answer.  1.01. What is the ratio of the Bank branche(per 100,000 adults) in San Marino in 2012 to that in 2013?
Give a very brief answer. 1.02. What is the ratio of the Bank branche(per 100,000 adults) of St. Vincent and the Grenadines in 2012 to that in 2013?
Offer a very short reply. 1.01. What is the ratio of the Bank branche(per 100,000 adults) of Cambodia in 2012 to that in 2014?
Offer a very short reply. 0.78. What is the ratio of the Bank branche(per 100,000 adults) of Nepal in 2012 to that in 2014?
Make the answer very short. 0.99. What is the ratio of the Bank branche(per 100,000 adults) in San Marino in 2012 to that in 2014?
Provide a succinct answer. 1.07. What is the ratio of the Bank branche(per 100,000 adults) of St. Vincent and the Grenadines in 2012 to that in 2014?
Your response must be concise. 1.01. What is the ratio of the Bank branche(per 100,000 adults) in Cambodia in 2013 to that in 2014?
Your answer should be very brief. 0.84. What is the ratio of the Bank branche(per 100,000 adults) of Nepal in 2013 to that in 2014?
Ensure brevity in your answer.  0.99. What is the ratio of the Bank branche(per 100,000 adults) in San Marino in 2013 to that in 2014?
Your answer should be compact. 1.05. What is the ratio of the Bank branche(per 100,000 adults) of St. Vincent and the Grenadines in 2013 to that in 2014?
Keep it short and to the point. 1.01. What is the difference between the highest and the second highest Bank branche(per 100,000 adults) in Cambodia?
Your answer should be very brief. 0.92. What is the difference between the highest and the second highest Bank branche(per 100,000 adults) in Nepal?
Provide a short and direct response. 0.04. What is the difference between the highest and the second highest Bank branche(per 100,000 adults) in San Marino?
Keep it short and to the point. 1.49. What is the difference between the highest and the second highest Bank branche(per 100,000 adults) in St. Vincent and the Grenadines?
Provide a succinct answer. 0.12. What is the difference between the highest and the lowest Bank branche(per 100,000 adults) in Cambodia?
Offer a terse response. 1.72. What is the difference between the highest and the lowest Bank branche(per 100,000 adults) of Nepal?
Offer a terse response. 3.76. What is the difference between the highest and the lowest Bank branche(per 100,000 adults) in San Marino?
Your answer should be very brief. 34.61. What is the difference between the highest and the lowest Bank branche(per 100,000 adults) of St. Vincent and the Grenadines?
Ensure brevity in your answer.  0.6. 